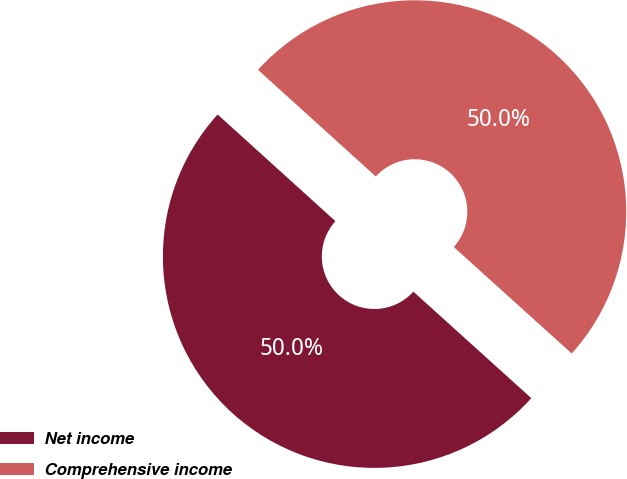<chart> <loc_0><loc_0><loc_500><loc_500><pie_chart><fcel>Net income<fcel>Comprehensive income<nl><fcel>50.02%<fcel>49.98%<nl></chart> 